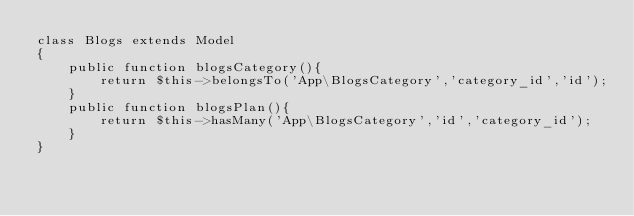<code> <loc_0><loc_0><loc_500><loc_500><_PHP_>class Blogs extends Model
{
    public function blogsCategory(){
        return $this->belongsTo('App\BlogsCategory','category_id','id');
    }
    public function blogsPlan(){
        return $this->hasMany('App\BlogsCategory','id','category_id');
    }
}</code> 